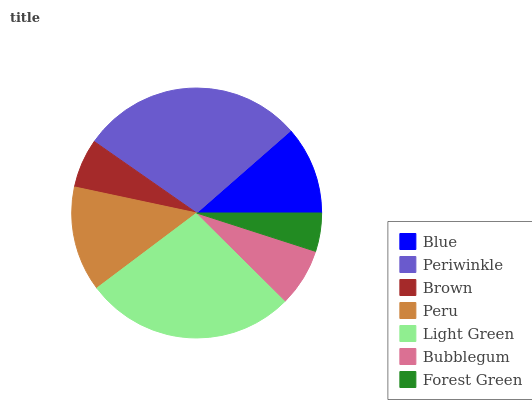Is Forest Green the minimum?
Answer yes or no. Yes. Is Periwinkle the maximum?
Answer yes or no. Yes. Is Brown the minimum?
Answer yes or no. No. Is Brown the maximum?
Answer yes or no. No. Is Periwinkle greater than Brown?
Answer yes or no. Yes. Is Brown less than Periwinkle?
Answer yes or no. Yes. Is Brown greater than Periwinkle?
Answer yes or no. No. Is Periwinkle less than Brown?
Answer yes or no. No. Is Blue the high median?
Answer yes or no. Yes. Is Blue the low median?
Answer yes or no. Yes. Is Forest Green the high median?
Answer yes or no. No. Is Forest Green the low median?
Answer yes or no. No. 